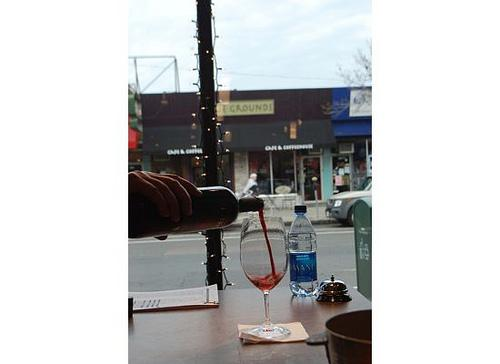Question: where are stores?
Choices:
A. Down the street.
B. Out the window.
C. Across town.
D. Twenty miles away.
Answer with the letter. Answer: B Question: how many glasses are on the table?
Choices:
A. One.
B. Two.
C. Three.
D. Four.
Answer with the letter. Answer: A Question: what is blue?
Choices:
A. The grass.
B. The mountain.
C. The sky.
D. The man's jacket.
Answer with the letter. Answer: C 